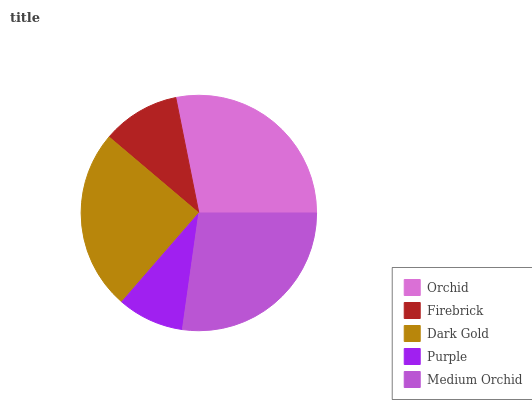Is Purple the minimum?
Answer yes or no. Yes. Is Orchid the maximum?
Answer yes or no. Yes. Is Firebrick the minimum?
Answer yes or no. No. Is Firebrick the maximum?
Answer yes or no. No. Is Orchid greater than Firebrick?
Answer yes or no. Yes. Is Firebrick less than Orchid?
Answer yes or no. Yes. Is Firebrick greater than Orchid?
Answer yes or no. No. Is Orchid less than Firebrick?
Answer yes or no. No. Is Dark Gold the high median?
Answer yes or no. Yes. Is Dark Gold the low median?
Answer yes or no. Yes. Is Firebrick the high median?
Answer yes or no. No. Is Purple the low median?
Answer yes or no. No. 